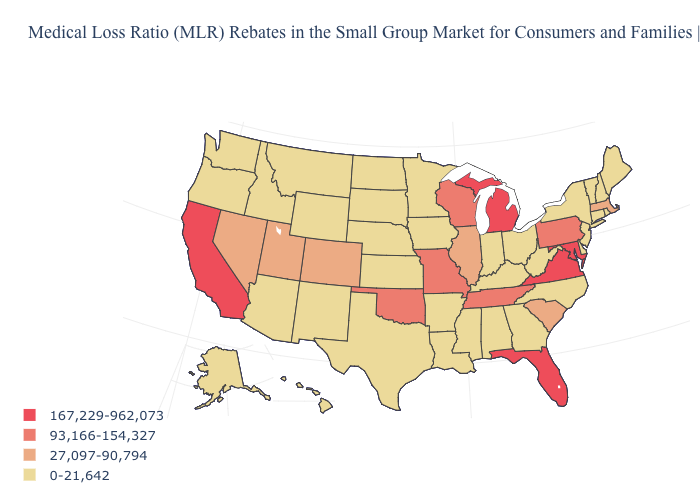Among the states that border Nevada , which have the highest value?
Answer briefly. California. What is the value of New Jersey?
Be succinct. 0-21,642. Which states have the lowest value in the MidWest?
Quick response, please. Indiana, Iowa, Kansas, Minnesota, Nebraska, North Dakota, Ohio, South Dakota. What is the lowest value in the West?
Concise answer only. 0-21,642. Does South Carolina have a lower value than Nebraska?
Give a very brief answer. No. Name the states that have a value in the range 167,229-962,073?
Short answer required. California, Florida, Maryland, Michigan, Virginia. What is the value of Mississippi?
Give a very brief answer. 0-21,642. Among the states that border New Hampshire , which have the highest value?
Quick response, please. Massachusetts. What is the value of Hawaii?
Concise answer only. 0-21,642. What is the value of Oregon?
Write a very short answer. 0-21,642. What is the highest value in the USA?
Be succinct. 167,229-962,073. Does South Carolina have the same value as Georgia?
Quick response, please. No. What is the value of Nevada?
Write a very short answer. 27,097-90,794. What is the value of Pennsylvania?
Concise answer only. 93,166-154,327. Does Idaho have a lower value than Kansas?
Keep it brief. No. 